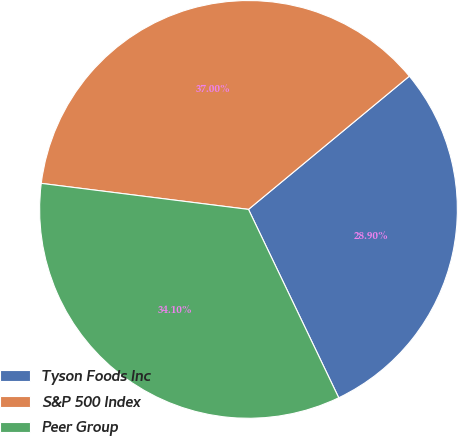<chart> <loc_0><loc_0><loc_500><loc_500><pie_chart><fcel>Tyson Foods Inc<fcel>S&P 500 Index<fcel>Peer Group<nl><fcel>28.9%<fcel>37.0%<fcel>34.1%<nl></chart> 